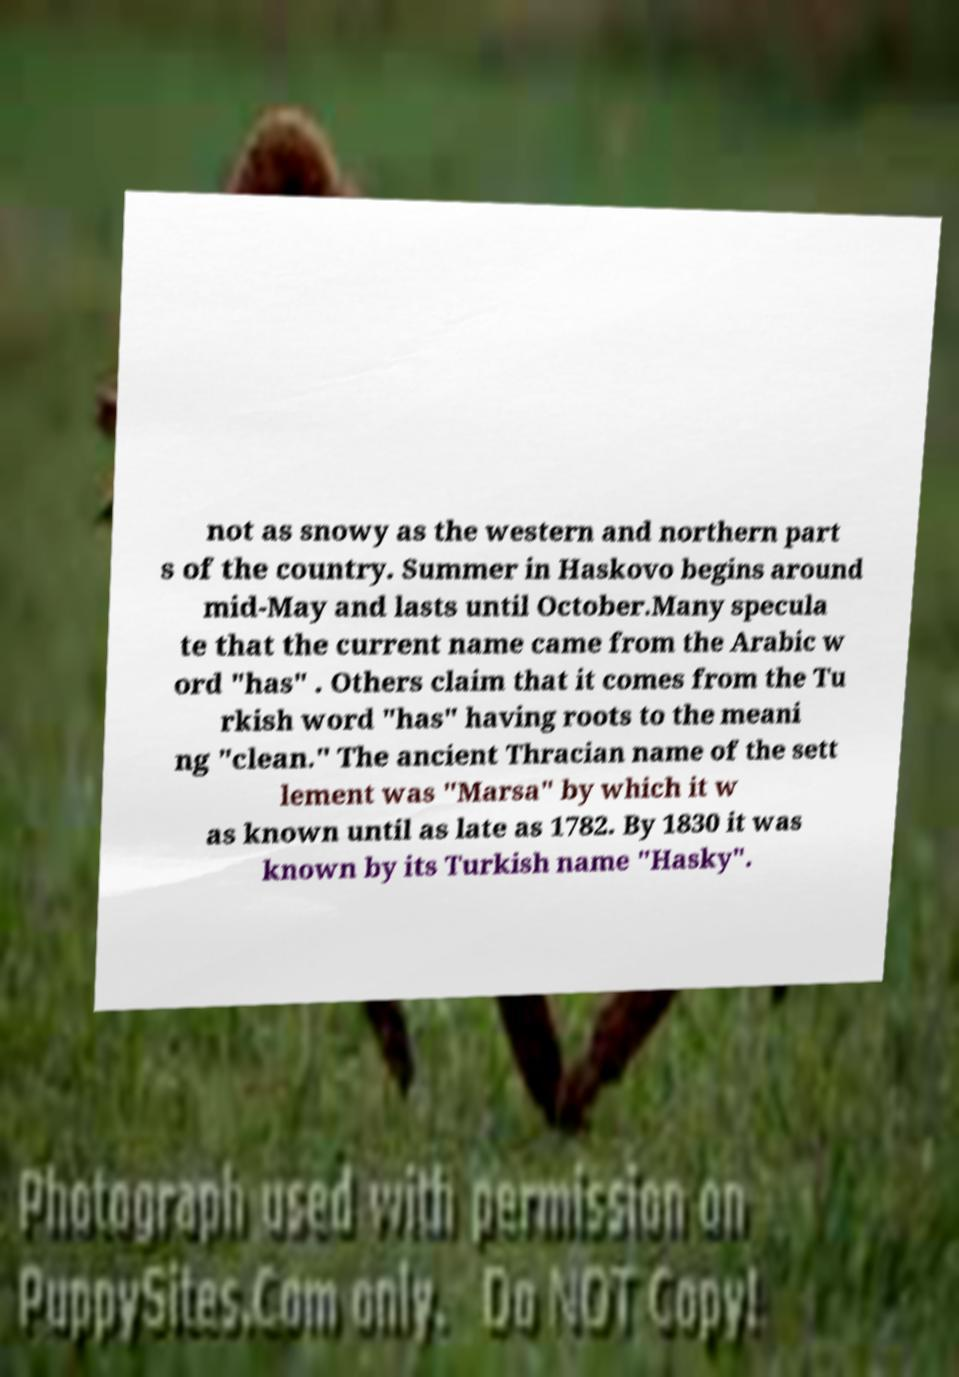Please read and relay the text visible in this image. What does it say? not as snowy as the western and northern part s of the country. Summer in Haskovo begins around mid-May and lasts until October.Many specula te that the current name came from the Arabic w ord "has" . Others claim that it comes from the Tu rkish word "has" having roots to the meani ng "clean." The ancient Thracian name of the sett lement was "Marsa" by which it w as known until as late as 1782. By 1830 it was known by its Turkish name "Hasky". 